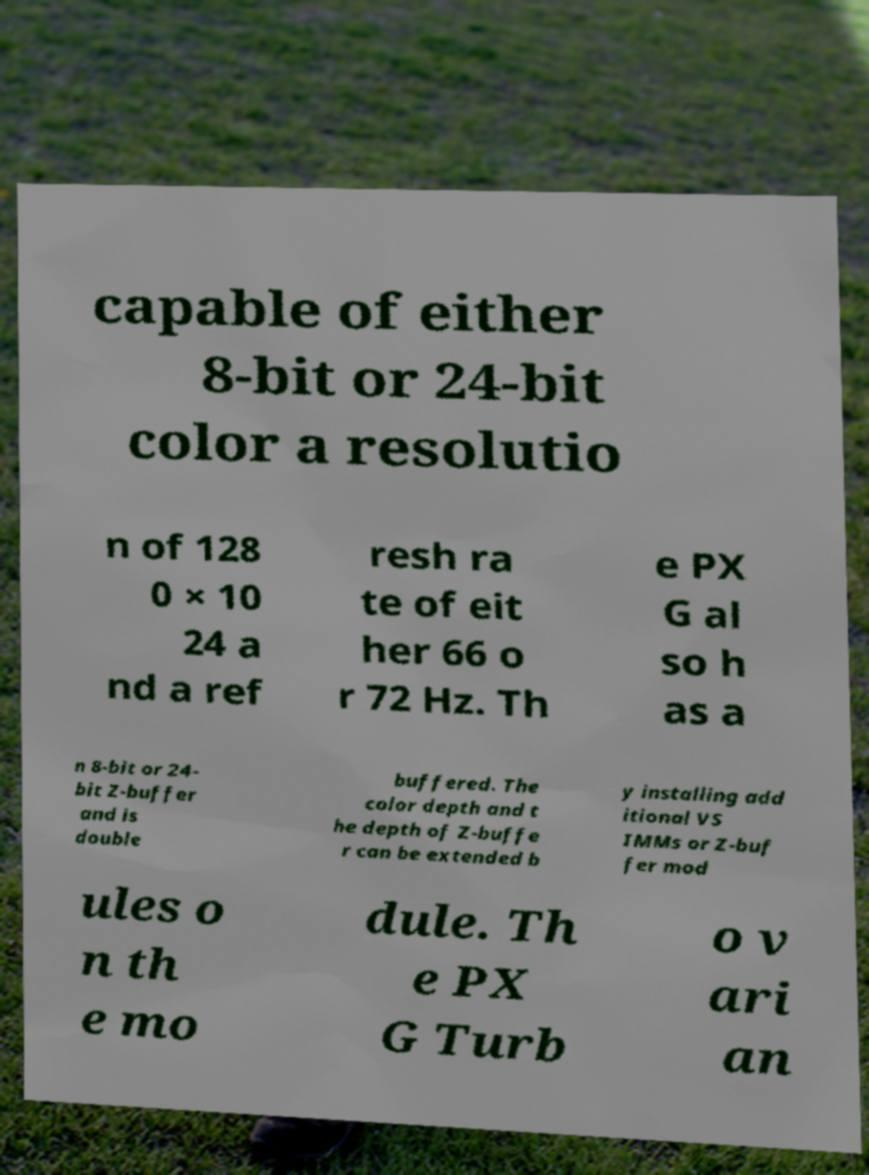Could you assist in decoding the text presented in this image and type it out clearly? capable of either 8-bit or 24-bit color a resolutio n of 128 0 × 10 24 a nd a ref resh ra te of eit her 66 o r 72 Hz. Th e PX G al so h as a n 8-bit or 24- bit Z-buffer and is double buffered. The color depth and t he depth of Z-buffe r can be extended b y installing add itional VS IMMs or Z-buf fer mod ules o n th e mo dule. Th e PX G Turb o v ari an 